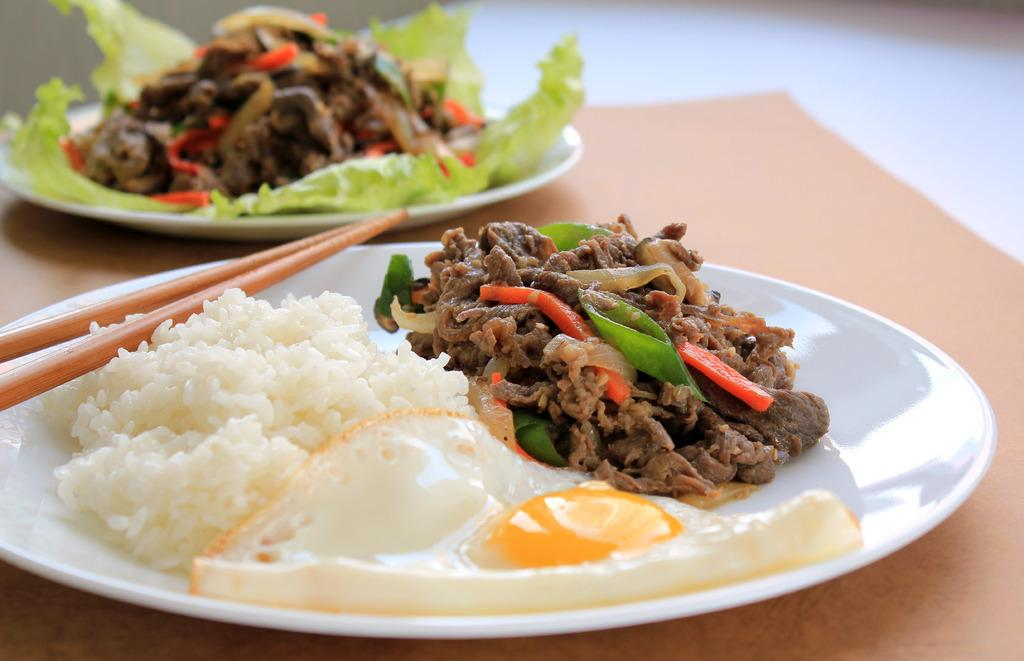What is the main subject of the image? The main subject of the image is food. How are the food items arranged in the image? The food is on white plates. Can you read the letter that is touching the food in the image? There is no letter present in the image, and the food is not being touched by any object. 